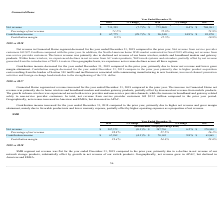According to Netgear's financial document, What accounts for the decrease in contribution income in 2019? Based on the financial document, the answer is Lower gross margin attainment, partially offset by lower operating expenses as a proportion of net revenue.. Also, What accounts for the increase in net revenue in 2018? Based on the financial document, the answer is Due to growth in switches, partially offset by the decrease in network storage.. Also, Which regions did the net revenue decline in 2019? According to the financial document, Americas and EMEA. The relevant text states: "period. Geographically, net revenue increased in Americas and EMEA, but decreased in APAC...." Also, can you calculate: What was the percentage change in net revenue from 2017 to 2019? To answer this question, I need to perform calculations using the financial data. The calculation is: (287,372-270,908)/270,908 , which equals 6.08 (percentage). This is based on the information: "Net revenue $ 287,372 (0.1)% $ 287,756 6.2% $ 270,908 Net revenue $ 287,372 (0.1)% $ 287,756 6.2% $ 270,908..." The key data points involved are: 270,908, 287,372. Additionally, In which year is the contribution margin the highest? According to the financial document, 2018. The relevant text states: "2019 % Change 2018 % Change 2017..." Also, can you calculate: What was the change in contribution income from 2017 to 2018? Based on the calculation: $70,142 - $63,865 , the result is 6277 (in thousands). This is based on the information: "ntribution income $ 67,282 (4.1)% $ 70,142 9.8% $ 63,865 Contribution income $ 67,282 (4.1)% $ 70,142 9.8% $ 63,865..." The key data points involved are: 63,865, 70,142. 